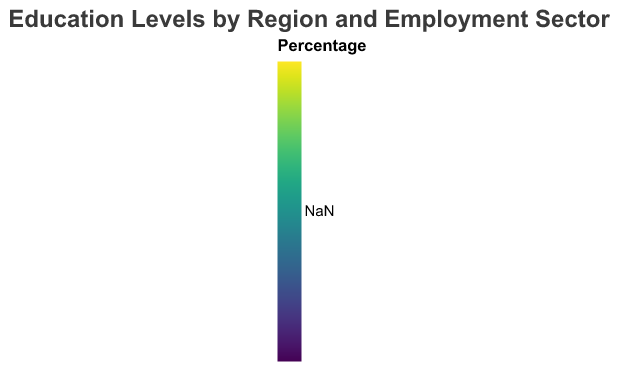What is the title of the heatmap? The title is clearly displayed at the top of the figure.
Answer: Education Levels by Region and Employment Sector Which region has the highest percentage of employees with a Doctorate in Healthcare? Check the heatmap and locate the highest color intensity for the Doctorate education level in the Healthcare sector across regions.
Answer: Europe Which employment sector in North America has the highest percentage of workers with a Bachelors degree? Compare the color intensity for the Bachelors degree within different sectors in North America.
Answer: Technology In which region does the Finance sector have the most employees with an Associate degree? Determine which region has the darkest color for the Associate level in the Finance sector.
Answer: Africa Which education level has the most similar percentage range across all regions for the Technology sector? By examining the color consistency for each education level in the Technology sector across all regions, we can see which has the least color variation.
Answer: Bachelors What is the average percentage of employees with a Masters degree in the Technology sector across all regions? Sum the percentages of employees with a Masters degree in the Technology sector across all regions and divide by the number of regions (6).
Answer: (25 + 15 + 30 + 20 + 10 + 25) / 6 = 20.83 Which region has the highest overall educational level (Doctorate) across all sectors? Find the region that shows the highest color intensity for the Doctorate degree across all sectors, or add up the percentages for Doctorate in all sectors within each region and compare.
Answer: Europe Do Finance sector employees in Asia or Oceania have a higher percentage of Bachelors degree holders? Compare the percentages for Bachelors degree holders in the Finance sector between Asia and Oceania.
Answer: Asia What is the total percentage of High School graduates in the Healthcare sector across all regions? Sum the percentages of High School graduates in the Healthcare sector for all regions.
Answer: 10 + 8 + 5 + 8 + 14 + 7 = 52 